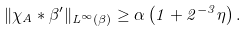<formula> <loc_0><loc_0><loc_500><loc_500>\| \chi _ { A } \ast \beta ^ { \prime } \| _ { L ^ { \infty } ( \beta ) } \geq \alpha \left ( 1 + 2 ^ { - 3 } \eta \right ) .</formula> 